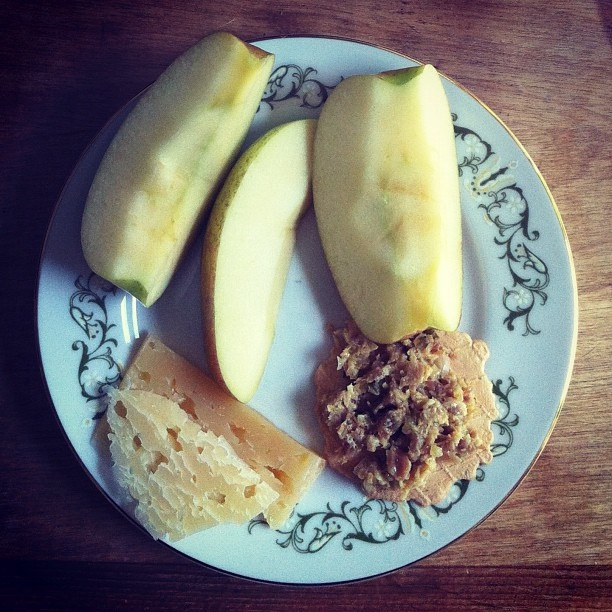Describe the objects in this image and their specific colors. I can see dining table in black, gray, lightblue, tan, and khaki tones, apple in black, olive, khaki, lightyellow, and gray tones, apple in black, gray, khaki, and tan tones, and apple in black, lightyellow, maroon, and olive tones in this image. 